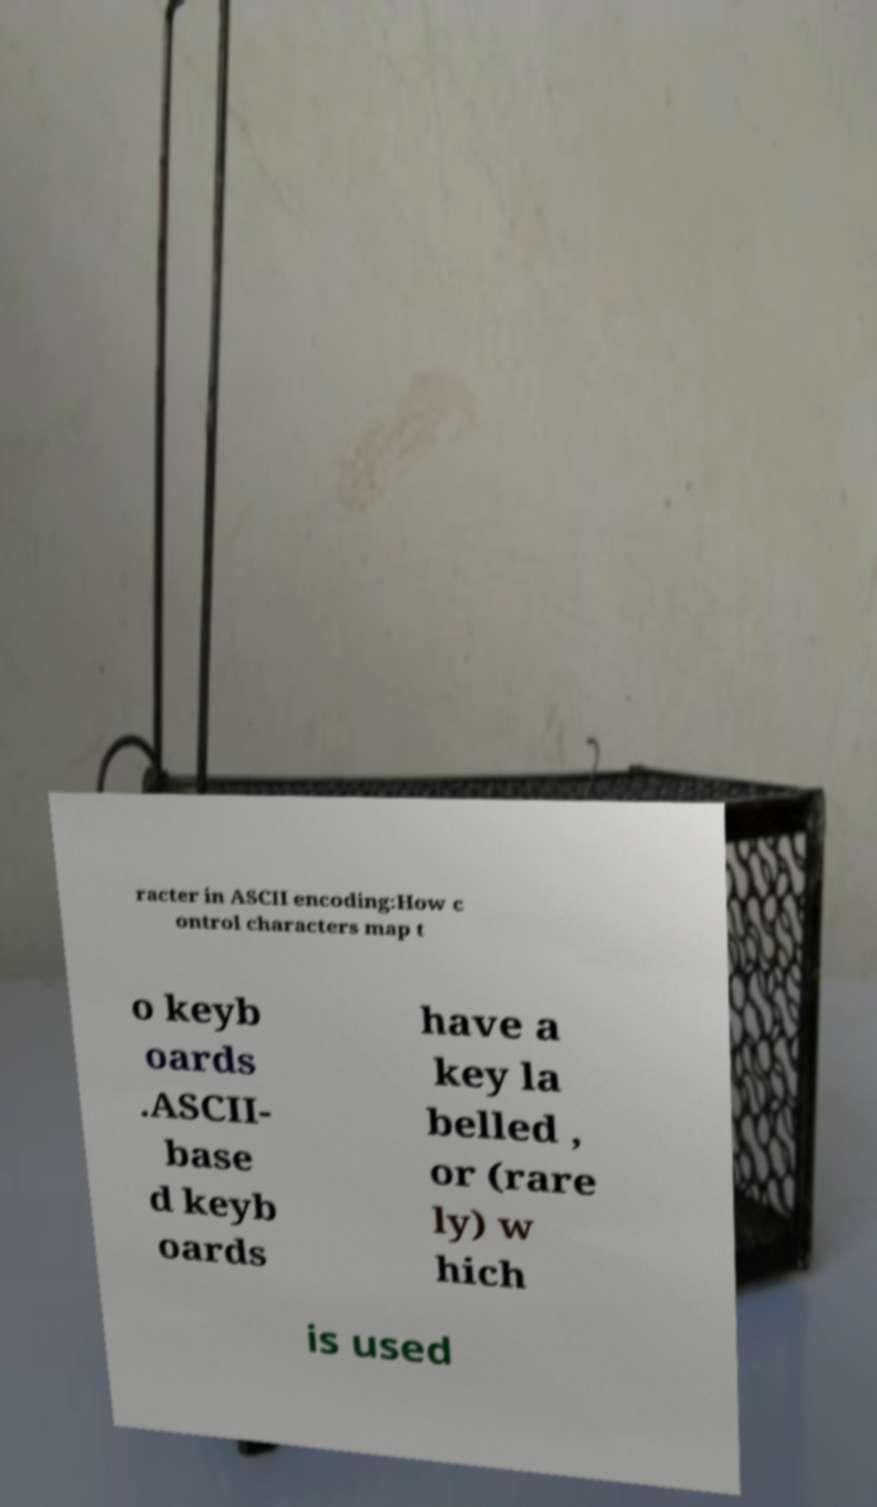Could you extract and type out the text from this image? racter in ASCII encoding:How c ontrol characters map t o keyb oards .ASCII- base d keyb oards have a key la belled , or (rare ly) w hich is used 